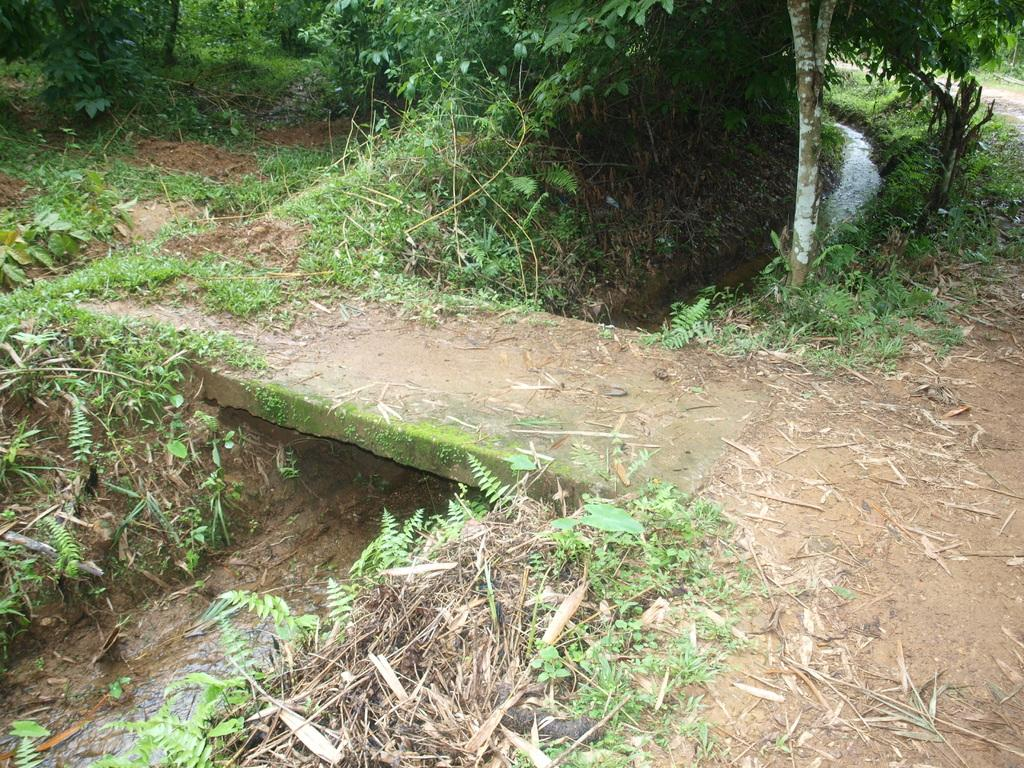What type of vegetation can be seen in the image? There is grass in the image. What else can be seen besides grass? There is water and trees visible in the image. Where is the throne located in the image? There is no throne present in the image. What type of bushes can be seen in the image? There are no bushes mentioned in the provided facts, and they are not visible in the image. 